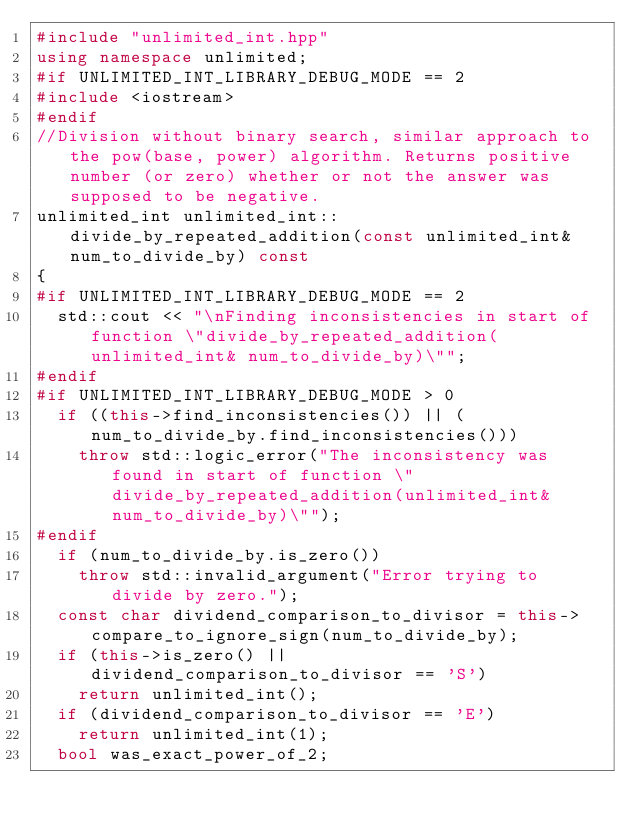Convert code to text. <code><loc_0><loc_0><loc_500><loc_500><_C++_>#include "unlimited_int.hpp"
using namespace unlimited;
#if UNLIMITED_INT_LIBRARY_DEBUG_MODE == 2
#include <iostream>
#endif
//Division without binary search, similar approach to the pow(base, power) algorithm. Returns positive number (or zero) whether or not the answer was supposed to be negative.
unlimited_int unlimited_int::divide_by_repeated_addition(const unlimited_int& num_to_divide_by) const
{
#if UNLIMITED_INT_LIBRARY_DEBUG_MODE == 2
	std::cout << "\nFinding inconsistencies in start of function \"divide_by_repeated_addition(unlimited_int& num_to_divide_by)\"";
#endif
#if UNLIMITED_INT_LIBRARY_DEBUG_MODE > 0
	if ((this->find_inconsistencies()) || (num_to_divide_by.find_inconsistencies()))
		throw std::logic_error("The inconsistency was found in start of function \"divide_by_repeated_addition(unlimited_int& num_to_divide_by)\"");
#endif
	if (num_to_divide_by.is_zero())
		throw std::invalid_argument("Error trying to divide by zero.");
	const char dividend_comparison_to_divisor = this->compare_to_ignore_sign(num_to_divide_by);
	if (this->is_zero() || dividend_comparison_to_divisor == 'S')
		return unlimited_int();
	if (dividend_comparison_to_divisor == 'E')
		return unlimited_int(1);
	bool was_exact_power_of_2;</code> 